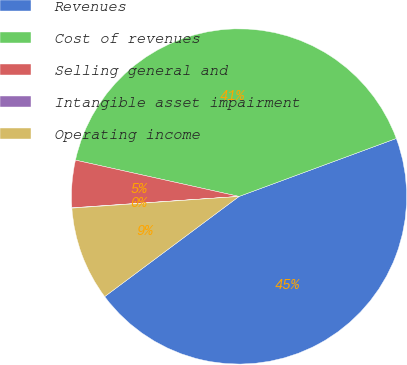Convert chart. <chart><loc_0><loc_0><loc_500><loc_500><pie_chart><fcel>Revenues<fcel>Cost of revenues<fcel>Selling general and<fcel>Intangible asset impairment<fcel>Operating income<nl><fcel>45.43%<fcel>40.9%<fcel>4.56%<fcel>0.03%<fcel>9.08%<nl></chart> 